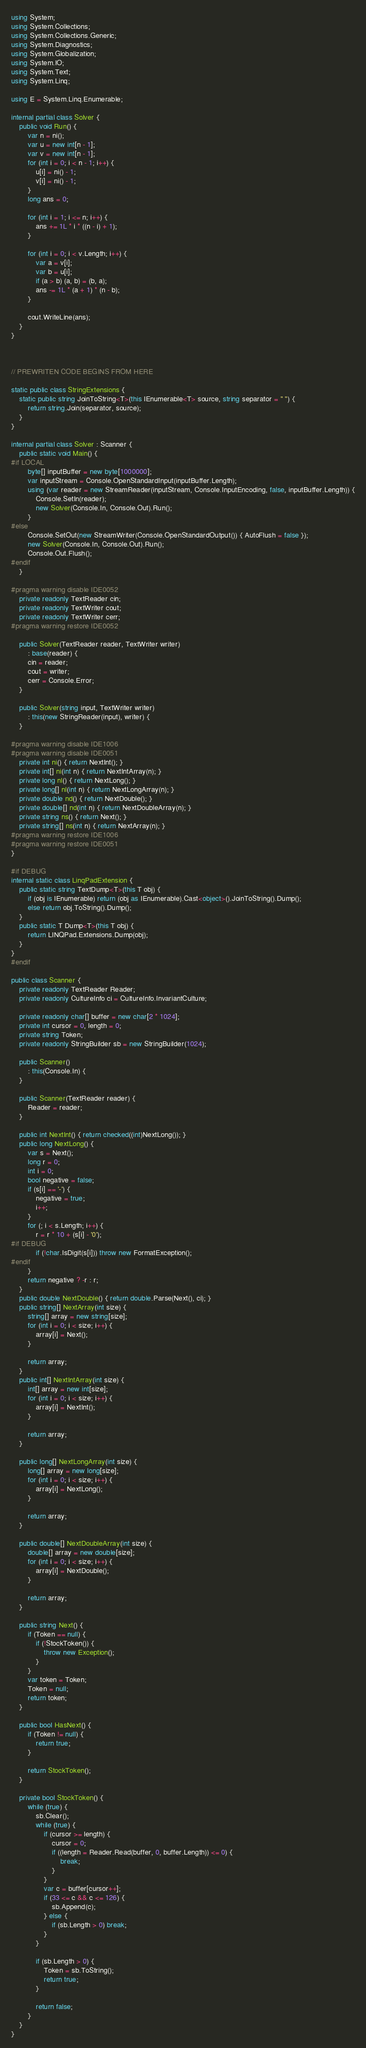<code> <loc_0><loc_0><loc_500><loc_500><_C#_>using System;
using System.Collections;
using System.Collections.Generic;
using System.Diagnostics;
using System.Globalization;
using System.IO;
using System.Text;
using System.Linq;

using E = System.Linq.Enumerable;

internal partial class Solver {
    public void Run() {
        var n = ni();
        var u = new int[n - 1];
        var v = new int[n - 1];
        for (int i = 0; i < n - 1; i++) {
            u[i] = ni() - 1;
            v[i] = ni() - 1;
        }
        long ans = 0;

        for (int i = 1; i <= n; i++) {
            ans += 1L * i * ((n - i) + 1);
        }

        for (int i = 0; i < v.Length; i++) {
            var a = v[i];
            var b = u[i];
            if (a > b) (a, b) = (b, a);
            ans -= 1L * (a + 1) * (n - b);
        }

        cout.WriteLine(ans);
    }
}



// PREWRITEN CODE BEGINS FROM HERE

static public class StringExtensions {
    static public string JoinToString<T>(this IEnumerable<T> source, string separator = " ") {
        return string.Join(separator, source);
    }
}

internal partial class Solver : Scanner {
    public static void Main() {
#if LOCAL
        byte[] inputBuffer = new byte[1000000];
        var inputStream = Console.OpenStandardInput(inputBuffer.Length);
        using (var reader = new StreamReader(inputStream, Console.InputEncoding, false, inputBuffer.Length)) {
            Console.SetIn(reader);
            new Solver(Console.In, Console.Out).Run();
        }
#else
        Console.SetOut(new StreamWriter(Console.OpenStandardOutput()) { AutoFlush = false });
        new Solver(Console.In, Console.Out).Run();
        Console.Out.Flush();
#endif
    }

#pragma warning disable IDE0052
    private readonly TextReader cin;
    private readonly TextWriter cout;
    private readonly TextWriter cerr;
#pragma warning restore IDE0052

    public Solver(TextReader reader, TextWriter writer)
        : base(reader) {
        cin = reader;
        cout = writer;
        cerr = Console.Error;
    }

    public Solver(string input, TextWriter writer)
        : this(new StringReader(input), writer) {
    }

#pragma warning disable IDE1006
#pragma warning disable IDE0051
    private int ni() { return NextInt(); }
    private int[] ni(int n) { return NextIntArray(n); }
    private long nl() { return NextLong(); }
    private long[] nl(int n) { return NextLongArray(n); }
    private double nd() { return NextDouble(); }
    private double[] nd(int n) { return NextDoubleArray(n); }
    private string ns() { return Next(); }
    private string[] ns(int n) { return NextArray(n); }
#pragma warning restore IDE1006
#pragma warning restore IDE0051
}

#if DEBUG
internal static class LinqPadExtension {
    public static string TextDump<T>(this T obj) {
        if (obj is IEnumerable) return (obj as IEnumerable).Cast<object>().JoinToString().Dump();
        else return obj.ToString().Dump();
    }
    public static T Dump<T>(this T obj) {
        return LINQPad.Extensions.Dump(obj);
    }
}
#endif

public class Scanner {
    private readonly TextReader Reader;
    private readonly CultureInfo ci = CultureInfo.InvariantCulture;

    private readonly char[] buffer = new char[2 * 1024];
    private int cursor = 0, length = 0;
    private string Token;
    private readonly StringBuilder sb = new StringBuilder(1024);

    public Scanner()
        : this(Console.In) {
    }

    public Scanner(TextReader reader) {
        Reader = reader;
    }

    public int NextInt() { return checked((int)NextLong()); }
    public long NextLong() {
        var s = Next();
        long r = 0;
        int i = 0;
        bool negative = false;
        if (s[i] == '-') {
            negative = true;
            i++;
        }
        for (; i < s.Length; i++) {
            r = r * 10 + (s[i] - '0');
#if DEBUG
            if (!char.IsDigit(s[i])) throw new FormatException();
#endif
        }
        return negative ? -r : r;
    }
    public double NextDouble() { return double.Parse(Next(), ci); }
    public string[] NextArray(int size) {
        string[] array = new string[size];
        for (int i = 0; i < size; i++) {
            array[i] = Next();
        }

        return array;
    }
    public int[] NextIntArray(int size) {
        int[] array = new int[size];
        for (int i = 0; i < size; i++) {
            array[i] = NextInt();
        }

        return array;
    }

    public long[] NextLongArray(int size) {
        long[] array = new long[size];
        for (int i = 0; i < size; i++) {
            array[i] = NextLong();
        }

        return array;
    }

    public double[] NextDoubleArray(int size) {
        double[] array = new double[size];
        for (int i = 0; i < size; i++) {
            array[i] = NextDouble();
        }

        return array;
    }

    public string Next() {
        if (Token == null) {
            if (!StockToken()) {
                throw new Exception();
            }
        }
        var token = Token;
        Token = null;
        return token;
    }

    public bool HasNext() {
        if (Token != null) {
            return true;
        }

        return StockToken();
    }

    private bool StockToken() {
        while (true) {
            sb.Clear();
            while (true) {
                if (cursor >= length) {
                    cursor = 0;
                    if ((length = Reader.Read(buffer, 0, buffer.Length)) <= 0) {
                        break;
                    }
                }
                var c = buffer[cursor++];
                if (33 <= c && c <= 126) {
                    sb.Append(c);
                } else {
                    if (sb.Length > 0) break;
                }
            }

            if (sb.Length > 0) {
                Token = sb.ToString();
                return true;
            }

            return false;
        }
    }
}</code> 